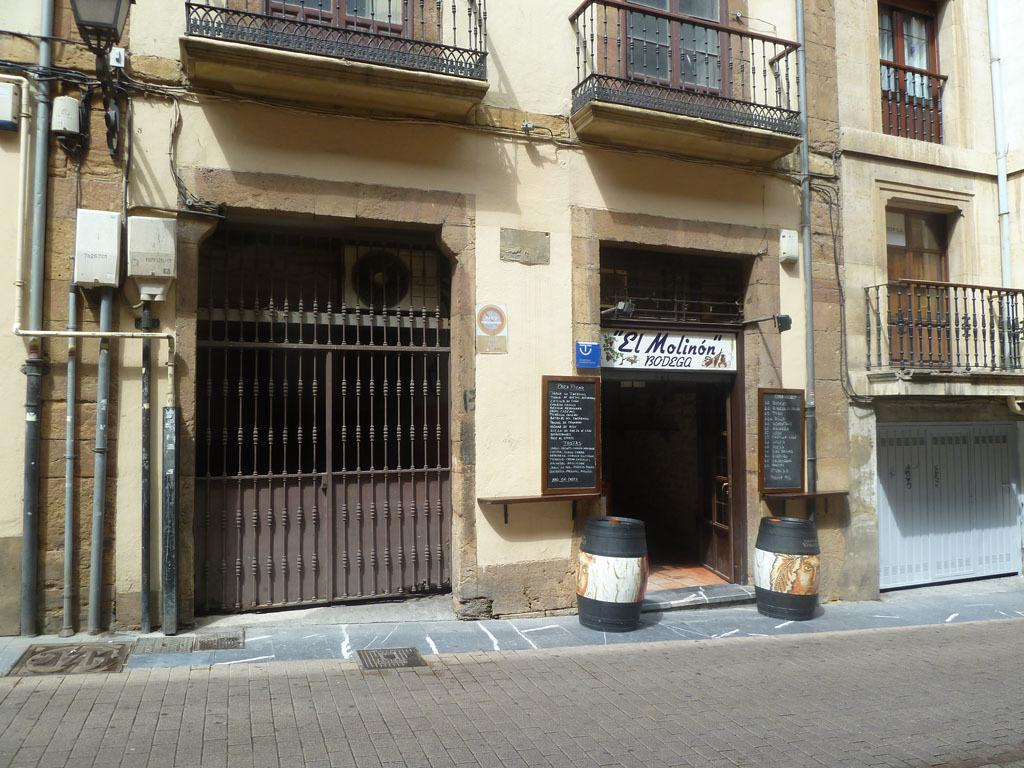What type of structure is present in the image? There is a building in the image. What feature can be seen on the building? The building has windows. What objects are present in the image besides the building? There are boards, wires, an iron gate, and a light visible in the image. What is written on the boards in the image? Something is written on the boards. What is the purpose of the iron gate in the image? The iron gate might be used for security or to control access to the building. How many beans are visible on the canvas in the image? There is no canvas or beans present in the image. 